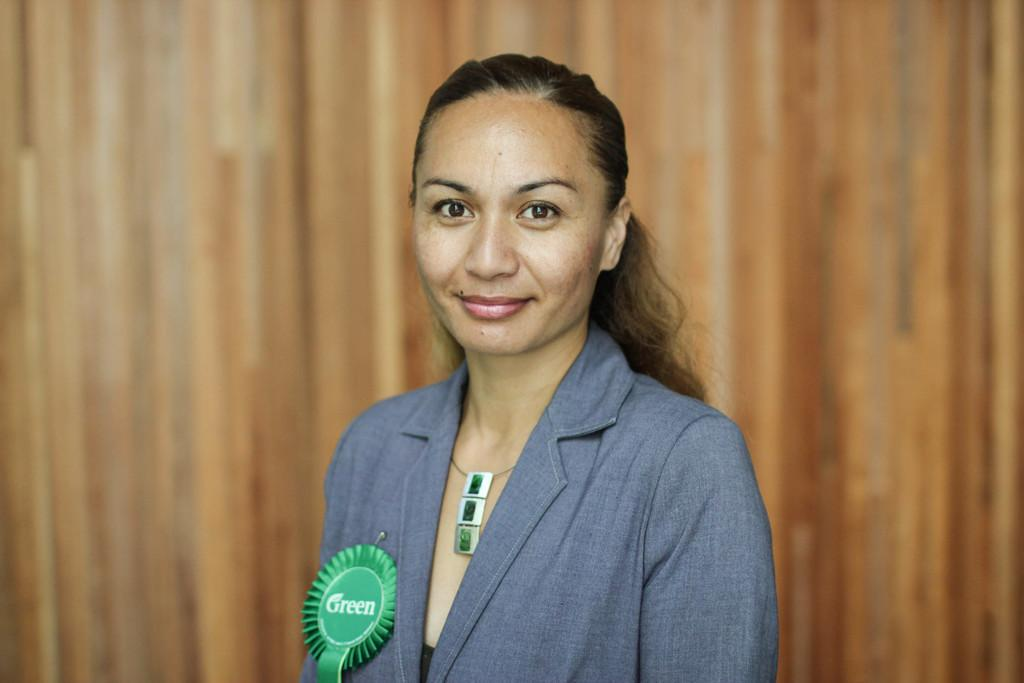Who is present in the image? There is a woman in the image. What is the green object in the image? There is a green batch in the image. What color is the background of the image? The background color is brown. What type of zinc can be seen in the image? There is no zinc present in the image. Is there any exchange happening between the woman and the green batch in the image? The image does not show any exchange between the woman and the green batch. 